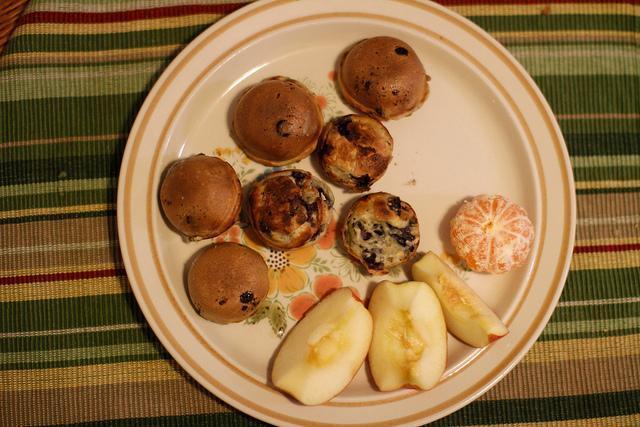How many food types are here?
Give a very brief answer. 3. How many teeth are on the plate?
Give a very brief answer. 0. How many donuts can be seen?
Give a very brief answer. 7. How many apples are there?
Give a very brief answer. 3. 